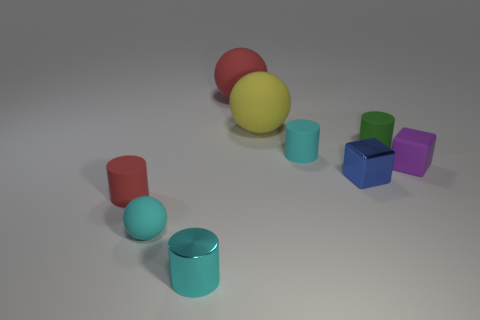There is a tiny cylinder that is behind the small purple rubber cube and on the left side of the tiny green thing; what material is it made of?
Ensure brevity in your answer.  Rubber. There is a purple matte object; what number of small green objects are behind it?
Keep it short and to the point. 1. Is the shape of the purple matte thing the same as the metal thing to the right of the red sphere?
Give a very brief answer. Yes. Is there a tiny blue object that has the same shape as the tiny purple rubber object?
Your answer should be compact. Yes. What is the shape of the tiny cyan object behind the matte sphere in front of the green rubber cylinder?
Ensure brevity in your answer.  Cylinder. What is the shape of the shiny thing that is in front of the tiny blue object?
Provide a short and direct response. Cylinder. There is a sphere that is in front of the tiny green rubber cylinder; is it the same color as the tiny metallic object on the left side of the large red matte sphere?
Make the answer very short. Yes. What number of blocks are right of the blue metallic thing and to the left of the small green cylinder?
Give a very brief answer. 0. There is a purple object that is the same material as the yellow thing; what size is it?
Your answer should be very brief. Small. How big is the purple cube?
Your response must be concise. Small. 